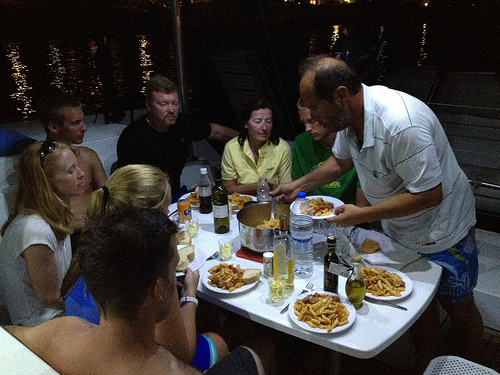Please provide a short description for this region: [0.58, 0.66, 0.65, 0.76]. This area predominantly depicts a stainless fork lying next to a white plate that holds food, likely enjoying an outdoor meal setting. 